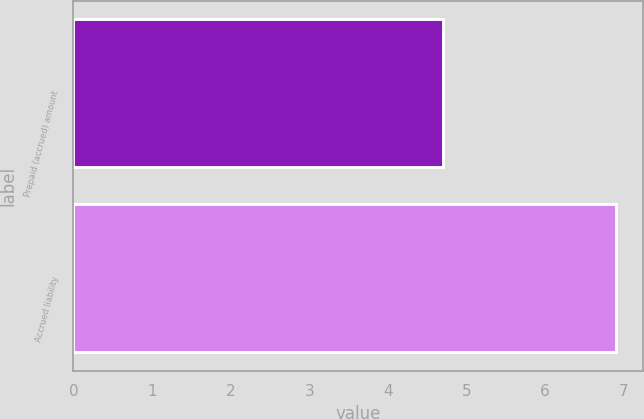Convert chart to OTSL. <chart><loc_0><loc_0><loc_500><loc_500><bar_chart><fcel>Prepaid (accrued) amount<fcel>Accrued liability<nl><fcel>4.7<fcel>6.9<nl></chart> 